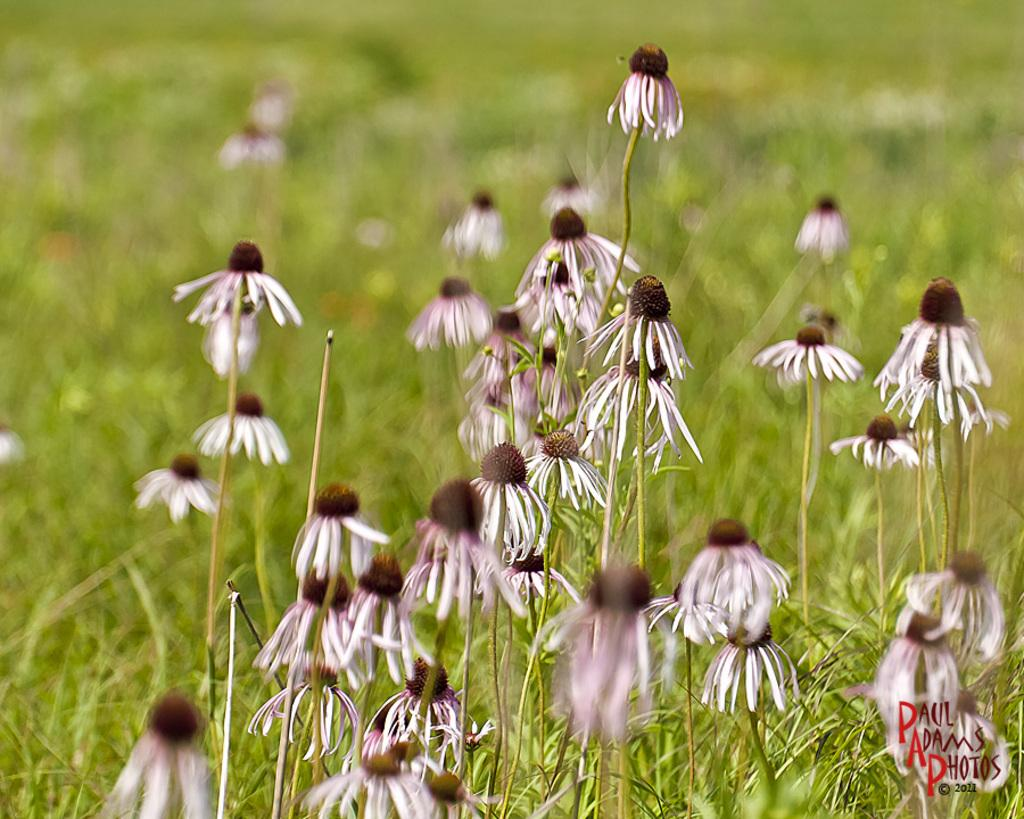What type of living organisms can be seen in the image? There are flowers on plants in the image. How would you describe the background of the image? The background of the image is blurred. Is there any text present in the image? Yes, there is text at the bottom of the image. What type of feather can be seen in the image? There is no feather present in the image; it features flowers on plants and text at the bottom. 